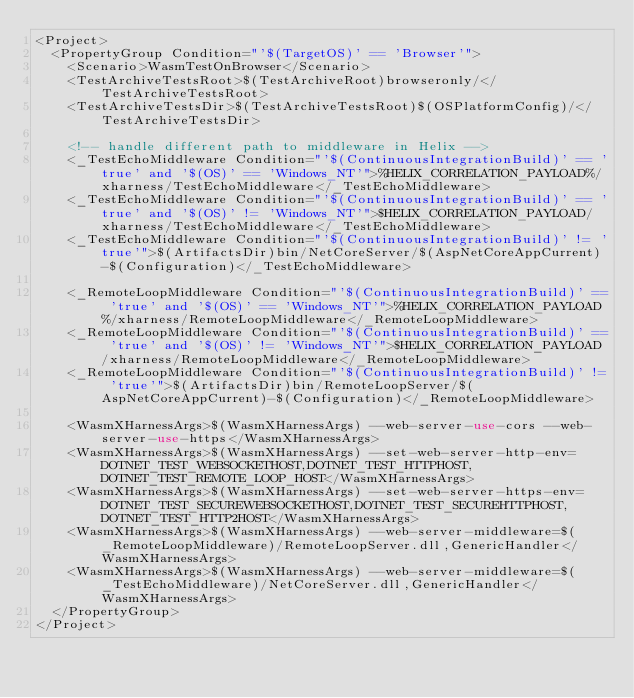Convert code to text. <code><loc_0><loc_0><loc_500><loc_500><_XML_><Project>
  <PropertyGroup Condition="'$(TargetOS)' == 'Browser'">
    <Scenario>WasmTestOnBrowser</Scenario>
    <TestArchiveTestsRoot>$(TestArchiveRoot)browseronly/</TestArchiveTestsRoot>
    <TestArchiveTestsDir>$(TestArchiveTestsRoot)$(OSPlatformConfig)/</TestArchiveTestsDir>

    <!-- handle different path to middleware in Helix -->
    <_TestEchoMiddleware Condition="'$(ContinuousIntegrationBuild)' == 'true' and '$(OS)' == 'Windows_NT'">%HELIX_CORRELATION_PAYLOAD%/xharness/TestEchoMiddleware</_TestEchoMiddleware>
    <_TestEchoMiddleware Condition="'$(ContinuousIntegrationBuild)' == 'true' and '$(OS)' != 'Windows_NT'">$HELIX_CORRELATION_PAYLOAD/xharness/TestEchoMiddleware</_TestEchoMiddleware>
    <_TestEchoMiddleware Condition="'$(ContinuousIntegrationBuild)' != 'true'">$(ArtifactsDir)bin/NetCoreServer/$(AspNetCoreAppCurrent)-$(Configuration)</_TestEchoMiddleware>

    <_RemoteLoopMiddleware Condition="'$(ContinuousIntegrationBuild)' == 'true' and '$(OS)' == 'Windows_NT'">%HELIX_CORRELATION_PAYLOAD%/xharness/RemoteLoopMiddleware</_RemoteLoopMiddleware>
    <_RemoteLoopMiddleware Condition="'$(ContinuousIntegrationBuild)' == 'true' and '$(OS)' != 'Windows_NT'">$HELIX_CORRELATION_PAYLOAD/xharness/RemoteLoopMiddleware</_RemoteLoopMiddleware>
    <_RemoteLoopMiddleware Condition="'$(ContinuousIntegrationBuild)' != 'true'">$(ArtifactsDir)bin/RemoteLoopServer/$(AspNetCoreAppCurrent)-$(Configuration)</_RemoteLoopMiddleware>

    <WasmXHarnessArgs>$(WasmXHarnessArgs) --web-server-use-cors --web-server-use-https</WasmXHarnessArgs>
    <WasmXHarnessArgs>$(WasmXHarnessArgs) --set-web-server-http-env=DOTNET_TEST_WEBSOCKETHOST,DOTNET_TEST_HTTPHOST,DOTNET_TEST_REMOTE_LOOP_HOST</WasmXHarnessArgs>
    <WasmXHarnessArgs>$(WasmXHarnessArgs) --set-web-server-https-env=DOTNET_TEST_SECUREWEBSOCKETHOST,DOTNET_TEST_SECUREHTTPHOST,DOTNET_TEST_HTTP2HOST</WasmXHarnessArgs>
    <WasmXHarnessArgs>$(WasmXHarnessArgs) --web-server-middleware=$(_RemoteLoopMiddleware)/RemoteLoopServer.dll,GenericHandler</WasmXHarnessArgs>
    <WasmXHarnessArgs>$(WasmXHarnessArgs) --web-server-middleware=$(_TestEchoMiddleware)/NetCoreServer.dll,GenericHandler</WasmXHarnessArgs>
  </PropertyGroup>
</Project>
</code> 